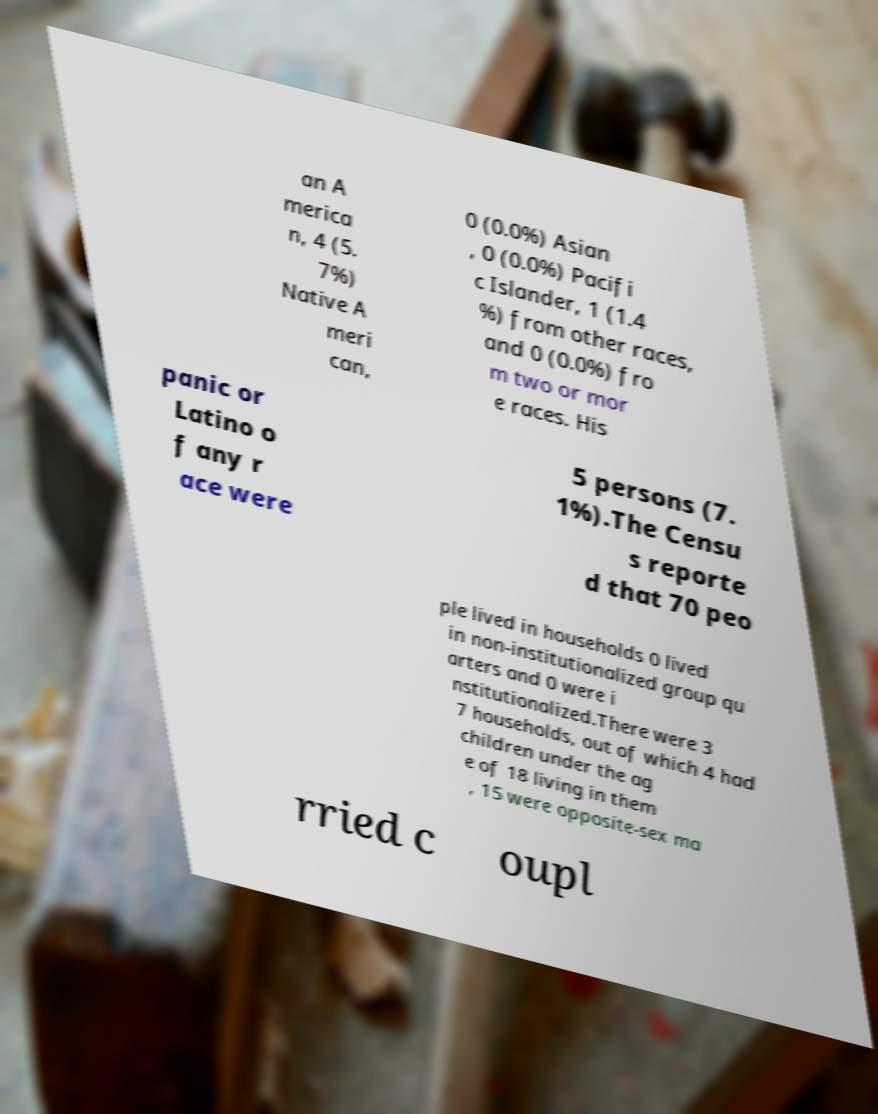There's text embedded in this image that I need extracted. Can you transcribe it verbatim? an A merica n, 4 (5. 7%) Native A meri can, 0 (0.0%) Asian , 0 (0.0%) Pacifi c Islander, 1 (1.4 %) from other races, and 0 (0.0%) fro m two or mor e races. His panic or Latino o f any r ace were 5 persons (7. 1%).The Censu s reporte d that 70 peo ple lived in households 0 lived in non-institutionalized group qu arters and 0 were i nstitutionalized.There were 3 7 households, out of which 4 had children under the ag e of 18 living in them , 15 were opposite-sex ma rried c oupl 